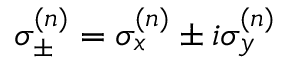<formula> <loc_0><loc_0><loc_500><loc_500>\sigma _ { \pm } ^ { ( n ) } = \sigma _ { x } ^ { ( n ) } \pm i \sigma _ { y } ^ { ( n ) }</formula> 